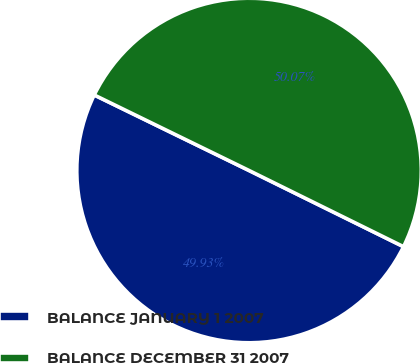Convert chart. <chart><loc_0><loc_0><loc_500><loc_500><pie_chart><fcel>BALANCE JANUARY 1 2007<fcel>BALANCE DECEMBER 31 2007<nl><fcel>49.93%<fcel>50.07%<nl></chart> 